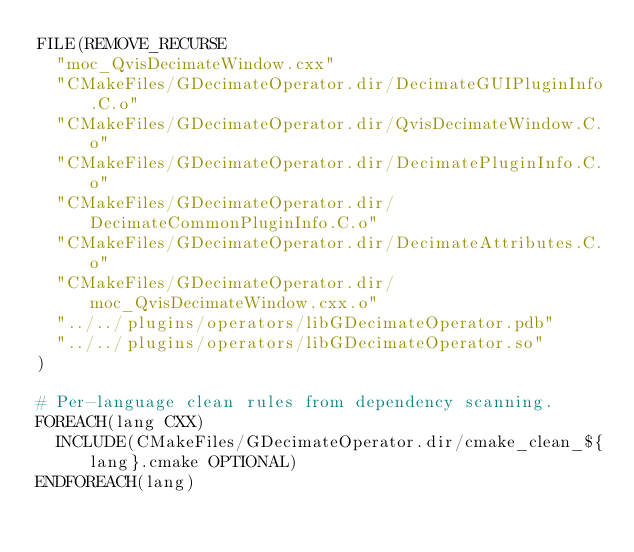Convert code to text. <code><loc_0><loc_0><loc_500><loc_500><_CMake_>FILE(REMOVE_RECURSE
  "moc_QvisDecimateWindow.cxx"
  "CMakeFiles/GDecimateOperator.dir/DecimateGUIPluginInfo.C.o"
  "CMakeFiles/GDecimateOperator.dir/QvisDecimateWindow.C.o"
  "CMakeFiles/GDecimateOperator.dir/DecimatePluginInfo.C.o"
  "CMakeFiles/GDecimateOperator.dir/DecimateCommonPluginInfo.C.o"
  "CMakeFiles/GDecimateOperator.dir/DecimateAttributes.C.o"
  "CMakeFiles/GDecimateOperator.dir/moc_QvisDecimateWindow.cxx.o"
  "../../plugins/operators/libGDecimateOperator.pdb"
  "../../plugins/operators/libGDecimateOperator.so"
)

# Per-language clean rules from dependency scanning.
FOREACH(lang CXX)
  INCLUDE(CMakeFiles/GDecimateOperator.dir/cmake_clean_${lang}.cmake OPTIONAL)
ENDFOREACH(lang)
</code> 